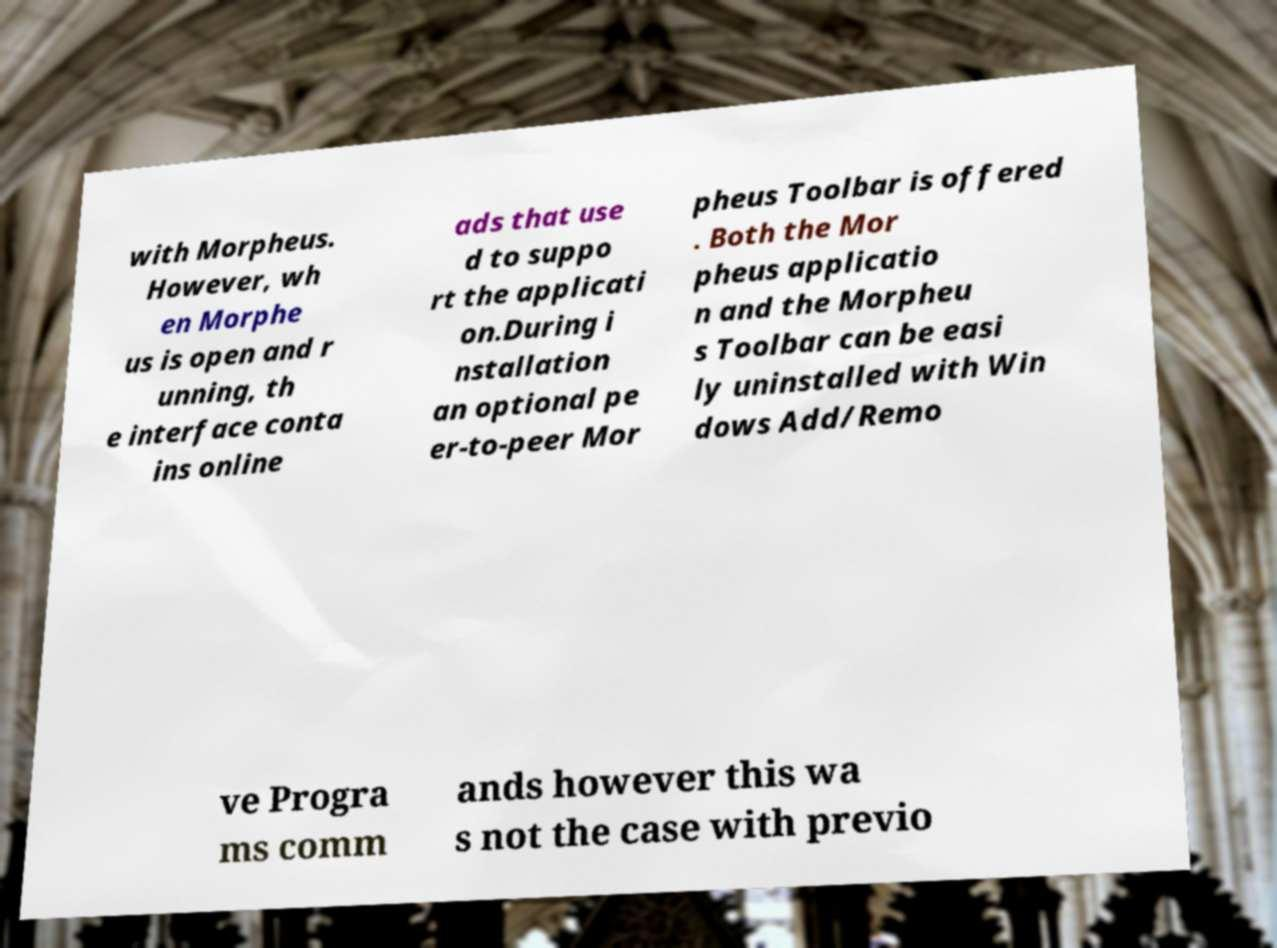I need the written content from this picture converted into text. Can you do that? with Morpheus. However, wh en Morphe us is open and r unning, th e interface conta ins online ads that use d to suppo rt the applicati on.During i nstallation an optional pe er-to-peer Mor pheus Toolbar is offered . Both the Mor pheus applicatio n and the Morpheu s Toolbar can be easi ly uninstalled with Win dows Add/Remo ve Progra ms comm ands however this wa s not the case with previo 